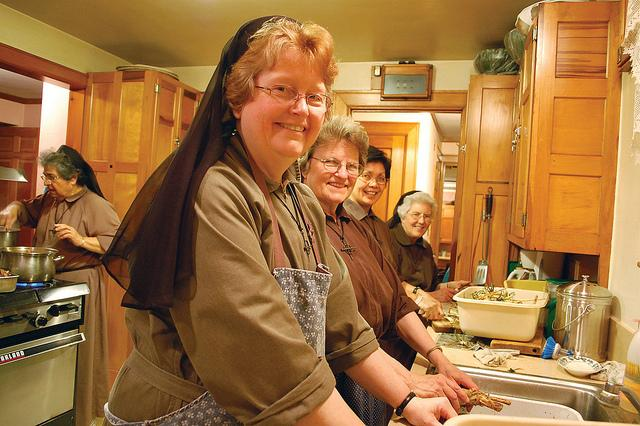What profession are these women in? Please explain your reasoning. nuns. They are wearing habits. habits are a special uniformfor women of the church. 